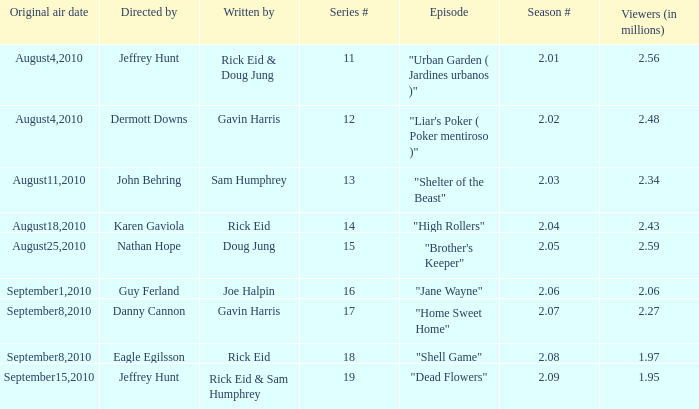If the season number is 2.08, who was the episode written by? Rick Eid. 